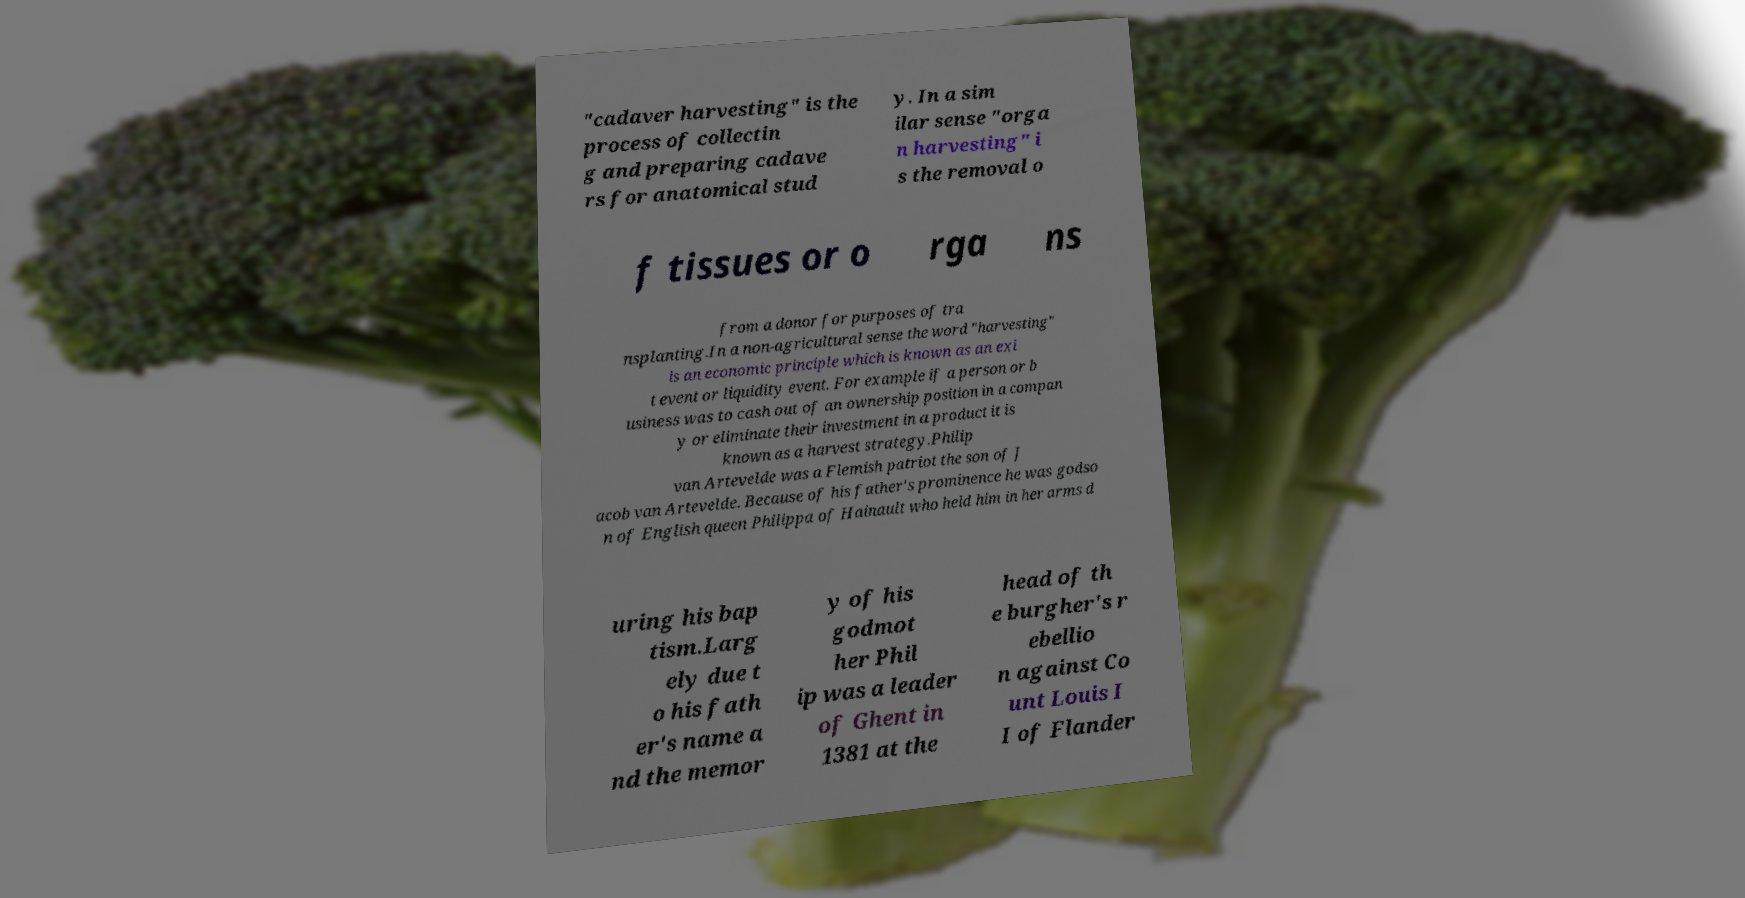For documentation purposes, I need the text within this image transcribed. Could you provide that? "cadaver harvesting" is the process of collectin g and preparing cadave rs for anatomical stud y. In a sim ilar sense "orga n harvesting" i s the removal o f tissues or o rga ns from a donor for purposes of tra nsplanting.In a non-agricultural sense the word "harvesting" is an economic principle which is known as an exi t event or liquidity event. For example if a person or b usiness was to cash out of an ownership position in a compan y or eliminate their investment in a product it is known as a harvest strategy.Philip van Artevelde was a Flemish patriot the son of J acob van Artevelde. Because of his father's prominence he was godso n of English queen Philippa of Hainault who held him in her arms d uring his bap tism.Larg ely due t o his fath er's name a nd the memor y of his godmot her Phil ip was a leader of Ghent in 1381 at the head of th e burgher's r ebellio n against Co unt Louis I I of Flander 